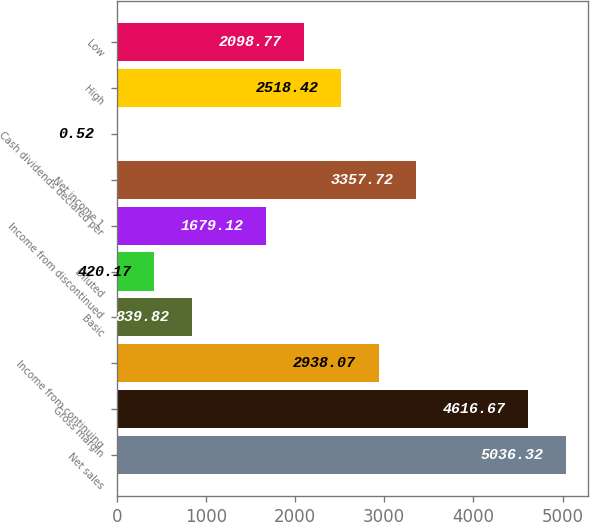<chart> <loc_0><loc_0><loc_500><loc_500><bar_chart><fcel>Net sales<fcel>Gross margin<fcel>Income from continuing<fcel>Basic<fcel>Diluted<fcel>Income from discontinued<fcel>Net income 1<fcel>Cash dividends declared per<fcel>High<fcel>Low<nl><fcel>5036.32<fcel>4616.67<fcel>2938.07<fcel>839.82<fcel>420.17<fcel>1679.12<fcel>3357.72<fcel>0.52<fcel>2518.42<fcel>2098.77<nl></chart> 